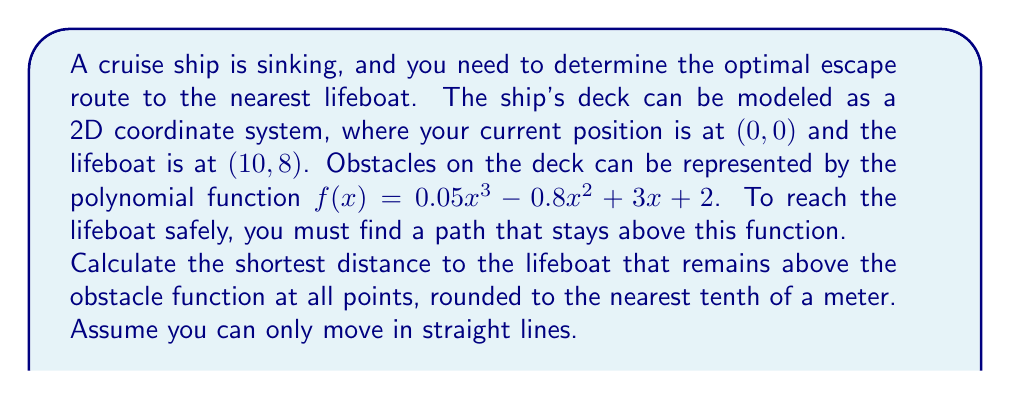Show me your answer to this math problem. To solve this problem, we need to follow these steps:

1) First, we need to determine if a straight line from (0, 0) to (10, 8) intersects with the obstacle function. We can do this by comparing the y-values of the line and the function at several points.

2) The equation of the straight line from (0, 0) to (10, 8) is:
   $y = \frac{8}{10}x = 0.8x$

3) Let's compare this with the obstacle function at x = 0, 5, and 10:

   At x = 0:
   Line: $y = 0.8(0) = 0$
   Obstacle: $f(0) = 0.05(0)^3 - 0.8(0)^2 + 3(0) + 2 = 2$
   The line is below the obstacle.

   At x = 5:
   Line: $y = 0.8(5) = 4$
   Obstacle: $f(5) = 0.05(5)^3 - 0.8(5)^2 + 3(5) + 2 = 6.25$
   The line is below the obstacle.

   At x = 10:
   Line: $y = 0.8(10) = 8$
   Obstacle: $f(10) = 0.05(10)^3 - 0.8(10)^2 + 3(10) + 2 = 12$
   The line is below the obstacle.

4) Since the straight line is always below the obstacle function, we need to find a path that goes over the highest point of the obstacle within the range x = [0, 10].

5) To find the highest point, we differentiate $f(x)$ and set it to zero:
   $f'(x) = 0.15x^2 - 1.6x + 3$
   $0.15x^2 - 1.6x + 3 = 0$

6) Solving this quadratic equation:
   $x = \frac{1.6 \pm \sqrt{1.6^2 - 4(0.15)(3)}}{2(0.15)} \approx 3.67$ or $7.33$

7) The x-value within our range that gives the highest y-value is 3.67.

8) The height of the obstacle at this point is:
   $f(3.67) = 0.05(3.67)^3 - 0.8(3.67)^2 + 3(3.67) + 2 \approx 7.56$

9) Now, we can calculate the length of a path that goes from (0, 0) to (3.67, 7.56) to (10, 8):

   Distance = $\sqrt{3.67^2 + 7.56^2} + \sqrt{(10-3.67)^2 + (8-7.56)^2}$
             $\approx 8.39 + 6.35 = 14.74$

10) Rounding to the nearest tenth, we get 14.7 meters.
Answer: 14.7 meters 